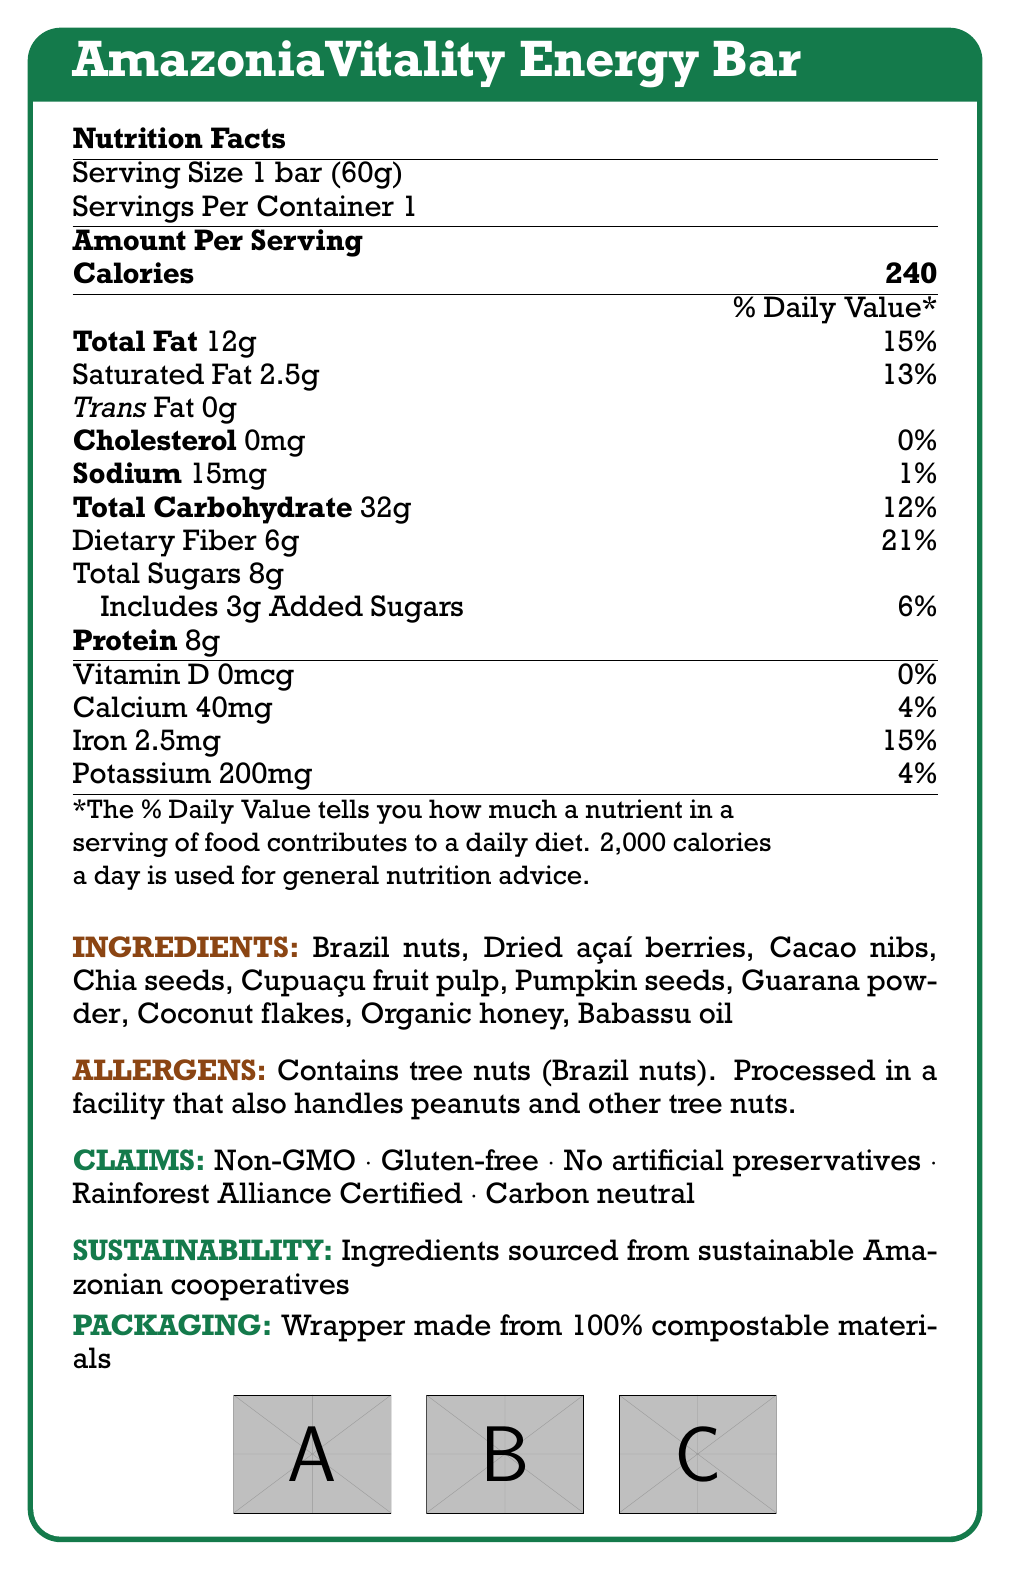what is the serving size of the AmazoniaVitality Energy Bar? The serving size information is explicitly mentioned in the document as "Serving Size 1 bar (60g)".
Answer: 1 bar (60g) How many calories are in one bar? The document states the number of calories in bold as "Calories 240".
Answer: 240 What is the total fat content per serving? The document lists "Total Fat" with the corresponding amount of 12g.
Answer: 12g Does the energy bar contain any trans fats? The document lists "Trans Fat 0g", indicating that there are no trans fats.
Answer: No What percentage of the daily value of iron does one bar provide? The document states "Iron 2.5mg" and "15%" as the daily value percentage.
Answer: 15% What is the amount of added sugars in the energy bar? The document specifies "Includes 3g Added Sugars" under the "Total Sugars" section.
Answer: 3g Which ingredient is not listed in the ingredients? A. Brazil nuts B. Dried açaí berries C. Almonds D. Guarana powder The document lists multiple ingredients, and almonds are not included in that list.
Answer: C What claims are made about the energy bar? A. Non-GMO B. Gluten-free C. Contains artificial preservatives D. Rainforest Alliance Certified The document claims "Non-GMO", "Gluten-free", "No artificial preservatives", and "Rainforest Alliance Certified". Hence, the correct answer is "Contains artificial preservatives".
Answer: C Is the packaging of the AmazoniaVitality Energy Bar compostable? The document mentions that the wrapper is made from 100% compostable materials.
Answer: Yes Summarize the main idea of the document. The document describes the nutritional facts of the energy bar, mentions all ingredients, allergens, and sustainability details, and affirms the bar's eco-friendly packaging.
Answer: The document provides detailed nutritional information, ingredients, allergens, and sustainability claims for the AmazoniaVitality Energy Bar. It highlights that the bar is made from sustainable Amazonian superfoods and has environmentally friendly packaging. What is the main source of protein in the AmazoniaVitality Energy Bar? The document provides a list of ingredients but does not specify which one is the main source of protein.
Answer: Not enough information How many grams of dietary fiber does the energy bar contain? The document states "Dietary Fiber 6g" indicating the amount per serving.
Answer: 6g What is the percentage of the daily value of saturated fat in the energy bar? The document lists "Saturated Fat 2.5g" and "13%" under the daily value percentage.
Answer: 13% Does the product contain any gluten? The document lists "Gluten-free" under the claims, indicating that the product does not contain gluten.
Answer: No Where are the ingredients of the energy bar sourced from? The document specifies that the ingredients are "sourced from sustainable Amazonian cooperatives".
Answer: Sustainable Amazonian cooperatives Which of the following is NOT mentioned as an ingredient in the energy bar? A. Chia seeds B. Guarana powder C. Maple syrup D. Babassu oil The list of ingredients in the document does not include maple syrup.
Answer: C 